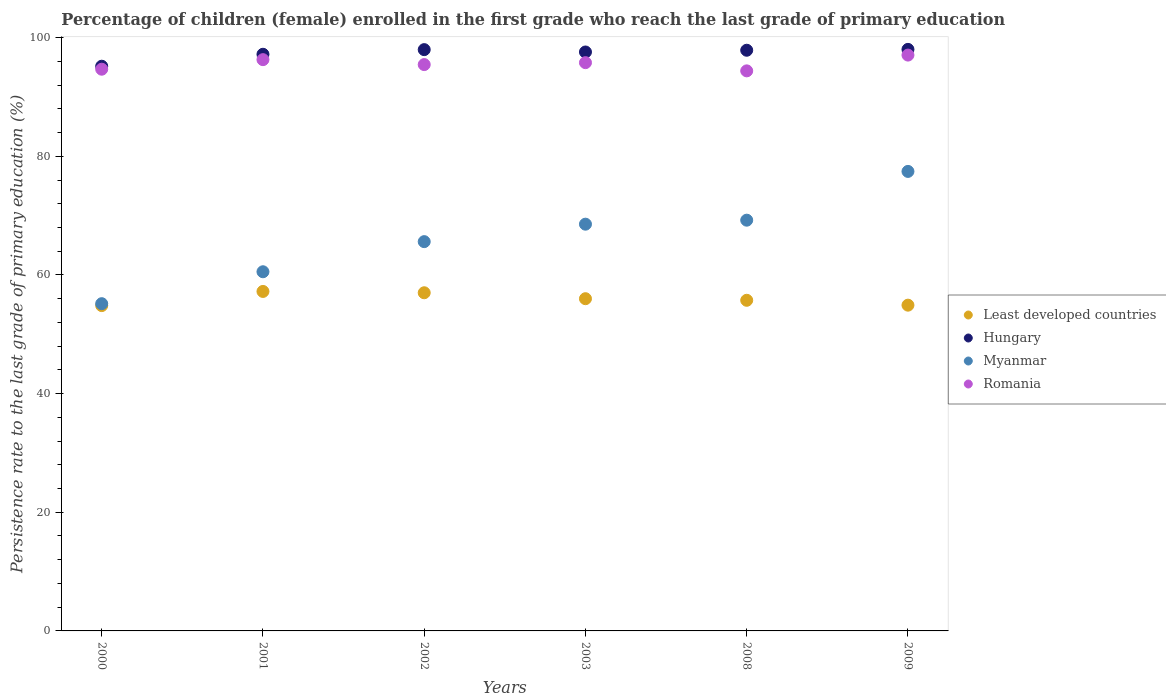What is the persistence rate of children in Romania in 2001?
Provide a short and direct response. 96.29. Across all years, what is the maximum persistence rate of children in Romania?
Make the answer very short. 97.06. Across all years, what is the minimum persistence rate of children in Romania?
Your answer should be compact. 94.4. In which year was the persistence rate of children in Myanmar maximum?
Provide a short and direct response. 2009. In which year was the persistence rate of children in Hungary minimum?
Provide a succinct answer. 2000. What is the total persistence rate of children in Least developed countries in the graph?
Provide a short and direct response. 335.69. What is the difference between the persistence rate of children in Least developed countries in 2000 and that in 2009?
Make the answer very short. -0.07. What is the difference between the persistence rate of children in Least developed countries in 2001 and the persistence rate of children in Romania in 2008?
Keep it short and to the point. -37.18. What is the average persistence rate of children in Least developed countries per year?
Keep it short and to the point. 55.95. In the year 2009, what is the difference between the persistence rate of children in Hungary and persistence rate of children in Romania?
Offer a very short reply. 0.96. What is the ratio of the persistence rate of children in Least developed countries in 2000 to that in 2003?
Provide a short and direct response. 0.98. Is the persistence rate of children in Myanmar in 2003 less than that in 2008?
Provide a succinct answer. Yes. What is the difference between the highest and the second highest persistence rate of children in Hungary?
Keep it short and to the point. 0.04. What is the difference between the highest and the lowest persistence rate of children in Least developed countries?
Make the answer very short. 2.38. In how many years, is the persistence rate of children in Myanmar greater than the average persistence rate of children in Myanmar taken over all years?
Keep it short and to the point. 3. Is it the case that in every year, the sum of the persistence rate of children in Myanmar and persistence rate of children in Hungary  is greater than the sum of persistence rate of children in Least developed countries and persistence rate of children in Romania?
Provide a short and direct response. No. Is it the case that in every year, the sum of the persistence rate of children in Hungary and persistence rate of children in Myanmar  is greater than the persistence rate of children in Romania?
Offer a very short reply. Yes. Is the persistence rate of children in Romania strictly greater than the persistence rate of children in Myanmar over the years?
Provide a succinct answer. Yes. What is the difference between two consecutive major ticks on the Y-axis?
Give a very brief answer. 20. Are the values on the major ticks of Y-axis written in scientific E-notation?
Provide a short and direct response. No. How are the legend labels stacked?
Ensure brevity in your answer.  Vertical. What is the title of the graph?
Give a very brief answer. Percentage of children (female) enrolled in the first grade who reach the last grade of primary education. What is the label or title of the Y-axis?
Make the answer very short. Persistence rate to the last grade of primary education (%). What is the Persistence rate to the last grade of primary education (%) in Least developed countries in 2000?
Make the answer very short. 54.84. What is the Persistence rate to the last grade of primary education (%) of Hungary in 2000?
Offer a very short reply. 95.18. What is the Persistence rate to the last grade of primary education (%) of Myanmar in 2000?
Your answer should be compact. 55.16. What is the Persistence rate to the last grade of primary education (%) of Romania in 2000?
Your answer should be very brief. 94.68. What is the Persistence rate to the last grade of primary education (%) in Least developed countries in 2001?
Your response must be concise. 57.22. What is the Persistence rate to the last grade of primary education (%) of Hungary in 2001?
Keep it short and to the point. 97.19. What is the Persistence rate to the last grade of primary education (%) in Myanmar in 2001?
Keep it short and to the point. 60.54. What is the Persistence rate to the last grade of primary education (%) of Romania in 2001?
Your response must be concise. 96.29. What is the Persistence rate to the last grade of primary education (%) in Least developed countries in 2002?
Ensure brevity in your answer.  57. What is the Persistence rate to the last grade of primary education (%) of Hungary in 2002?
Provide a succinct answer. 97.98. What is the Persistence rate to the last grade of primary education (%) of Myanmar in 2002?
Offer a very short reply. 65.61. What is the Persistence rate to the last grade of primary education (%) of Romania in 2002?
Provide a short and direct response. 95.46. What is the Persistence rate to the last grade of primary education (%) of Least developed countries in 2003?
Your response must be concise. 56. What is the Persistence rate to the last grade of primary education (%) in Hungary in 2003?
Give a very brief answer. 97.58. What is the Persistence rate to the last grade of primary education (%) in Myanmar in 2003?
Ensure brevity in your answer.  68.56. What is the Persistence rate to the last grade of primary education (%) of Romania in 2003?
Your response must be concise. 95.78. What is the Persistence rate to the last grade of primary education (%) of Least developed countries in 2008?
Offer a terse response. 55.73. What is the Persistence rate to the last grade of primary education (%) of Hungary in 2008?
Offer a terse response. 97.88. What is the Persistence rate to the last grade of primary education (%) of Myanmar in 2008?
Your response must be concise. 69.23. What is the Persistence rate to the last grade of primary education (%) of Romania in 2008?
Ensure brevity in your answer.  94.4. What is the Persistence rate to the last grade of primary education (%) of Least developed countries in 2009?
Offer a terse response. 54.91. What is the Persistence rate to the last grade of primary education (%) in Hungary in 2009?
Provide a short and direct response. 98.02. What is the Persistence rate to the last grade of primary education (%) of Myanmar in 2009?
Your answer should be compact. 77.45. What is the Persistence rate to the last grade of primary education (%) of Romania in 2009?
Keep it short and to the point. 97.06. Across all years, what is the maximum Persistence rate to the last grade of primary education (%) of Least developed countries?
Give a very brief answer. 57.22. Across all years, what is the maximum Persistence rate to the last grade of primary education (%) of Hungary?
Your response must be concise. 98.02. Across all years, what is the maximum Persistence rate to the last grade of primary education (%) of Myanmar?
Your answer should be compact. 77.45. Across all years, what is the maximum Persistence rate to the last grade of primary education (%) of Romania?
Make the answer very short. 97.06. Across all years, what is the minimum Persistence rate to the last grade of primary education (%) in Least developed countries?
Provide a succinct answer. 54.84. Across all years, what is the minimum Persistence rate to the last grade of primary education (%) in Hungary?
Your answer should be very brief. 95.18. Across all years, what is the minimum Persistence rate to the last grade of primary education (%) of Myanmar?
Offer a terse response. 55.16. Across all years, what is the minimum Persistence rate to the last grade of primary education (%) in Romania?
Ensure brevity in your answer.  94.4. What is the total Persistence rate to the last grade of primary education (%) of Least developed countries in the graph?
Your answer should be compact. 335.69. What is the total Persistence rate to the last grade of primary education (%) of Hungary in the graph?
Your response must be concise. 583.83. What is the total Persistence rate to the last grade of primary education (%) in Myanmar in the graph?
Your response must be concise. 396.55. What is the total Persistence rate to the last grade of primary education (%) of Romania in the graph?
Provide a succinct answer. 573.67. What is the difference between the Persistence rate to the last grade of primary education (%) in Least developed countries in 2000 and that in 2001?
Offer a very short reply. -2.38. What is the difference between the Persistence rate to the last grade of primary education (%) of Hungary in 2000 and that in 2001?
Keep it short and to the point. -2.01. What is the difference between the Persistence rate to the last grade of primary education (%) of Myanmar in 2000 and that in 2001?
Your answer should be compact. -5.38. What is the difference between the Persistence rate to the last grade of primary education (%) of Romania in 2000 and that in 2001?
Your answer should be compact. -1.61. What is the difference between the Persistence rate to the last grade of primary education (%) of Least developed countries in 2000 and that in 2002?
Offer a very short reply. -2.16. What is the difference between the Persistence rate to the last grade of primary education (%) in Hungary in 2000 and that in 2002?
Give a very brief answer. -2.8. What is the difference between the Persistence rate to the last grade of primary education (%) of Myanmar in 2000 and that in 2002?
Your response must be concise. -10.46. What is the difference between the Persistence rate to the last grade of primary education (%) in Romania in 2000 and that in 2002?
Provide a short and direct response. -0.78. What is the difference between the Persistence rate to the last grade of primary education (%) of Least developed countries in 2000 and that in 2003?
Give a very brief answer. -1.16. What is the difference between the Persistence rate to the last grade of primary education (%) of Hungary in 2000 and that in 2003?
Offer a very short reply. -2.4. What is the difference between the Persistence rate to the last grade of primary education (%) in Myanmar in 2000 and that in 2003?
Provide a short and direct response. -13.4. What is the difference between the Persistence rate to the last grade of primary education (%) of Romania in 2000 and that in 2003?
Keep it short and to the point. -1.11. What is the difference between the Persistence rate to the last grade of primary education (%) of Least developed countries in 2000 and that in 2008?
Offer a very short reply. -0.89. What is the difference between the Persistence rate to the last grade of primary education (%) of Hungary in 2000 and that in 2008?
Offer a very short reply. -2.69. What is the difference between the Persistence rate to the last grade of primary education (%) of Myanmar in 2000 and that in 2008?
Provide a short and direct response. -14.08. What is the difference between the Persistence rate to the last grade of primary education (%) in Romania in 2000 and that in 2008?
Make the answer very short. 0.28. What is the difference between the Persistence rate to the last grade of primary education (%) of Least developed countries in 2000 and that in 2009?
Give a very brief answer. -0.07. What is the difference between the Persistence rate to the last grade of primary education (%) in Hungary in 2000 and that in 2009?
Make the answer very short. -2.84. What is the difference between the Persistence rate to the last grade of primary education (%) in Myanmar in 2000 and that in 2009?
Provide a succinct answer. -22.29. What is the difference between the Persistence rate to the last grade of primary education (%) of Romania in 2000 and that in 2009?
Offer a terse response. -2.38. What is the difference between the Persistence rate to the last grade of primary education (%) of Least developed countries in 2001 and that in 2002?
Your response must be concise. 0.22. What is the difference between the Persistence rate to the last grade of primary education (%) in Hungary in 2001 and that in 2002?
Ensure brevity in your answer.  -0.78. What is the difference between the Persistence rate to the last grade of primary education (%) of Myanmar in 2001 and that in 2002?
Give a very brief answer. -5.08. What is the difference between the Persistence rate to the last grade of primary education (%) of Romania in 2001 and that in 2002?
Give a very brief answer. 0.83. What is the difference between the Persistence rate to the last grade of primary education (%) of Least developed countries in 2001 and that in 2003?
Your response must be concise. 1.22. What is the difference between the Persistence rate to the last grade of primary education (%) of Hungary in 2001 and that in 2003?
Your answer should be very brief. -0.39. What is the difference between the Persistence rate to the last grade of primary education (%) of Myanmar in 2001 and that in 2003?
Provide a short and direct response. -8.02. What is the difference between the Persistence rate to the last grade of primary education (%) of Romania in 2001 and that in 2003?
Provide a succinct answer. 0.51. What is the difference between the Persistence rate to the last grade of primary education (%) in Least developed countries in 2001 and that in 2008?
Provide a short and direct response. 1.49. What is the difference between the Persistence rate to the last grade of primary education (%) in Hungary in 2001 and that in 2008?
Offer a very short reply. -0.68. What is the difference between the Persistence rate to the last grade of primary education (%) of Myanmar in 2001 and that in 2008?
Your answer should be very brief. -8.69. What is the difference between the Persistence rate to the last grade of primary education (%) of Romania in 2001 and that in 2008?
Keep it short and to the point. 1.89. What is the difference between the Persistence rate to the last grade of primary education (%) of Least developed countries in 2001 and that in 2009?
Keep it short and to the point. 2.31. What is the difference between the Persistence rate to the last grade of primary education (%) in Hungary in 2001 and that in 2009?
Keep it short and to the point. -0.82. What is the difference between the Persistence rate to the last grade of primary education (%) of Myanmar in 2001 and that in 2009?
Keep it short and to the point. -16.91. What is the difference between the Persistence rate to the last grade of primary education (%) in Romania in 2001 and that in 2009?
Make the answer very short. -0.77. What is the difference between the Persistence rate to the last grade of primary education (%) in Hungary in 2002 and that in 2003?
Give a very brief answer. 0.4. What is the difference between the Persistence rate to the last grade of primary education (%) of Myanmar in 2002 and that in 2003?
Give a very brief answer. -2.94. What is the difference between the Persistence rate to the last grade of primary education (%) in Romania in 2002 and that in 2003?
Offer a very short reply. -0.33. What is the difference between the Persistence rate to the last grade of primary education (%) of Least developed countries in 2002 and that in 2008?
Your answer should be compact. 1.27. What is the difference between the Persistence rate to the last grade of primary education (%) of Hungary in 2002 and that in 2008?
Your answer should be compact. 0.1. What is the difference between the Persistence rate to the last grade of primary education (%) of Myanmar in 2002 and that in 2008?
Give a very brief answer. -3.62. What is the difference between the Persistence rate to the last grade of primary education (%) in Romania in 2002 and that in 2008?
Keep it short and to the point. 1.06. What is the difference between the Persistence rate to the last grade of primary education (%) of Least developed countries in 2002 and that in 2009?
Ensure brevity in your answer.  2.09. What is the difference between the Persistence rate to the last grade of primary education (%) of Hungary in 2002 and that in 2009?
Your answer should be very brief. -0.04. What is the difference between the Persistence rate to the last grade of primary education (%) of Myanmar in 2002 and that in 2009?
Provide a succinct answer. -11.84. What is the difference between the Persistence rate to the last grade of primary education (%) of Romania in 2002 and that in 2009?
Your answer should be compact. -1.6. What is the difference between the Persistence rate to the last grade of primary education (%) of Least developed countries in 2003 and that in 2008?
Your answer should be compact. 0.27. What is the difference between the Persistence rate to the last grade of primary education (%) in Hungary in 2003 and that in 2008?
Offer a terse response. -0.29. What is the difference between the Persistence rate to the last grade of primary education (%) of Myanmar in 2003 and that in 2008?
Your answer should be very brief. -0.67. What is the difference between the Persistence rate to the last grade of primary education (%) of Romania in 2003 and that in 2008?
Offer a very short reply. 1.38. What is the difference between the Persistence rate to the last grade of primary education (%) of Least developed countries in 2003 and that in 2009?
Provide a short and direct response. 1.09. What is the difference between the Persistence rate to the last grade of primary education (%) in Hungary in 2003 and that in 2009?
Give a very brief answer. -0.44. What is the difference between the Persistence rate to the last grade of primary education (%) in Myanmar in 2003 and that in 2009?
Provide a short and direct response. -8.89. What is the difference between the Persistence rate to the last grade of primary education (%) in Romania in 2003 and that in 2009?
Your response must be concise. -1.27. What is the difference between the Persistence rate to the last grade of primary education (%) in Least developed countries in 2008 and that in 2009?
Your answer should be compact. 0.82. What is the difference between the Persistence rate to the last grade of primary education (%) in Hungary in 2008 and that in 2009?
Offer a very short reply. -0.14. What is the difference between the Persistence rate to the last grade of primary education (%) in Myanmar in 2008 and that in 2009?
Provide a short and direct response. -8.22. What is the difference between the Persistence rate to the last grade of primary education (%) in Romania in 2008 and that in 2009?
Your answer should be very brief. -2.66. What is the difference between the Persistence rate to the last grade of primary education (%) in Least developed countries in 2000 and the Persistence rate to the last grade of primary education (%) in Hungary in 2001?
Make the answer very short. -42.36. What is the difference between the Persistence rate to the last grade of primary education (%) in Least developed countries in 2000 and the Persistence rate to the last grade of primary education (%) in Myanmar in 2001?
Offer a very short reply. -5.7. What is the difference between the Persistence rate to the last grade of primary education (%) in Least developed countries in 2000 and the Persistence rate to the last grade of primary education (%) in Romania in 2001?
Your answer should be very brief. -41.45. What is the difference between the Persistence rate to the last grade of primary education (%) of Hungary in 2000 and the Persistence rate to the last grade of primary education (%) of Myanmar in 2001?
Offer a very short reply. 34.64. What is the difference between the Persistence rate to the last grade of primary education (%) in Hungary in 2000 and the Persistence rate to the last grade of primary education (%) in Romania in 2001?
Make the answer very short. -1.11. What is the difference between the Persistence rate to the last grade of primary education (%) of Myanmar in 2000 and the Persistence rate to the last grade of primary education (%) of Romania in 2001?
Give a very brief answer. -41.13. What is the difference between the Persistence rate to the last grade of primary education (%) of Least developed countries in 2000 and the Persistence rate to the last grade of primary education (%) of Hungary in 2002?
Your answer should be very brief. -43.14. What is the difference between the Persistence rate to the last grade of primary education (%) of Least developed countries in 2000 and the Persistence rate to the last grade of primary education (%) of Myanmar in 2002?
Make the answer very short. -10.78. What is the difference between the Persistence rate to the last grade of primary education (%) in Least developed countries in 2000 and the Persistence rate to the last grade of primary education (%) in Romania in 2002?
Your answer should be compact. -40.62. What is the difference between the Persistence rate to the last grade of primary education (%) in Hungary in 2000 and the Persistence rate to the last grade of primary education (%) in Myanmar in 2002?
Your answer should be compact. 29.57. What is the difference between the Persistence rate to the last grade of primary education (%) of Hungary in 2000 and the Persistence rate to the last grade of primary education (%) of Romania in 2002?
Make the answer very short. -0.28. What is the difference between the Persistence rate to the last grade of primary education (%) of Myanmar in 2000 and the Persistence rate to the last grade of primary education (%) of Romania in 2002?
Provide a succinct answer. -40.3. What is the difference between the Persistence rate to the last grade of primary education (%) of Least developed countries in 2000 and the Persistence rate to the last grade of primary education (%) of Hungary in 2003?
Provide a succinct answer. -42.74. What is the difference between the Persistence rate to the last grade of primary education (%) in Least developed countries in 2000 and the Persistence rate to the last grade of primary education (%) in Myanmar in 2003?
Give a very brief answer. -13.72. What is the difference between the Persistence rate to the last grade of primary education (%) in Least developed countries in 2000 and the Persistence rate to the last grade of primary education (%) in Romania in 2003?
Keep it short and to the point. -40.95. What is the difference between the Persistence rate to the last grade of primary education (%) of Hungary in 2000 and the Persistence rate to the last grade of primary education (%) of Myanmar in 2003?
Provide a succinct answer. 26.62. What is the difference between the Persistence rate to the last grade of primary education (%) of Hungary in 2000 and the Persistence rate to the last grade of primary education (%) of Romania in 2003?
Provide a short and direct response. -0.6. What is the difference between the Persistence rate to the last grade of primary education (%) in Myanmar in 2000 and the Persistence rate to the last grade of primary education (%) in Romania in 2003?
Give a very brief answer. -40.63. What is the difference between the Persistence rate to the last grade of primary education (%) in Least developed countries in 2000 and the Persistence rate to the last grade of primary education (%) in Hungary in 2008?
Offer a very short reply. -43.04. What is the difference between the Persistence rate to the last grade of primary education (%) of Least developed countries in 2000 and the Persistence rate to the last grade of primary education (%) of Myanmar in 2008?
Give a very brief answer. -14.4. What is the difference between the Persistence rate to the last grade of primary education (%) in Least developed countries in 2000 and the Persistence rate to the last grade of primary education (%) in Romania in 2008?
Provide a short and direct response. -39.56. What is the difference between the Persistence rate to the last grade of primary education (%) in Hungary in 2000 and the Persistence rate to the last grade of primary education (%) in Myanmar in 2008?
Your answer should be very brief. 25.95. What is the difference between the Persistence rate to the last grade of primary education (%) in Hungary in 2000 and the Persistence rate to the last grade of primary education (%) in Romania in 2008?
Make the answer very short. 0.78. What is the difference between the Persistence rate to the last grade of primary education (%) of Myanmar in 2000 and the Persistence rate to the last grade of primary education (%) of Romania in 2008?
Your answer should be compact. -39.24. What is the difference between the Persistence rate to the last grade of primary education (%) in Least developed countries in 2000 and the Persistence rate to the last grade of primary education (%) in Hungary in 2009?
Provide a short and direct response. -43.18. What is the difference between the Persistence rate to the last grade of primary education (%) in Least developed countries in 2000 and the Persistence rate to the last grade of primary education (%) in Myanmar in 2009?
Your response must be concise. -22.61. What is the difference between the Persistence rate to the last grade of primary education (%) of Least developed countries in 2000 and the Persistence rate to the last grade of primary education (%) of Romania in 2009?
Make the answer very short. -42.22. What is the difference between the Persistence rate to the last grade of primary education (%) in Hungary in 2000 and the Persistence rate to the last grade of primary education (%) in Myanmar in 2009?
Ensure brevity in your answer.  17.73. What is the difference between the Persistence rate to the last grade of primary education (%) in Hungary in 2000 and the Persistence rate to the last grade of primary education (%) in Romania in 2009?
Offer a very short reply. -1.88. What is the difference between the Persistence rate to the last grade of primary education (%) in Myanmar in 2000 and the Persistence rate to the last grade of primary education (%) in Romania in 2009?
Give a very brief answer. -41.9. What is the difference between the Persistence rate to the last grade of primary education (%) of Least developed countries in 2001 and the Persistence rate to the last grade of primary education (%) of Hungary in 2002?
Keep it short and to the point. -40.76. What is the difference between the Persistence rate to the last grade of primary education (%) of Least developed countries in 2001 and the Persistence rate to the last grade of primary education (%) of Myanmar in 2002?
Give a very brief answer. -8.39. What is the difference between the Persistence rate to the last grade of primary education (%) of Least developed countries in 2001 and the Persistence rate to the last grade of primary education (%) of Romania in 2002?
Provide a succinct answer. -38.24. What is the difference between the Persistence rate to the last grade of primary education (%) of Hungary in 2001 and the Persistence rate to the last grade of primary education (%) of Myanmar in 2002?
Your answer should be very brief. 31.58. What is the difference between the Persistence rate to the last grade of primary education (%) in Hungary in 2001 and the Persistence rate to the last grade of primary education (%) in Romania in 2002?
Your response must be concise. 1.74. What is the difference between the Persistence rate to the last grade of primary education (%) of Myanmar in 2001 and the Persistence rate to the last grade of primary education (%) of Romania in 2002?
Offer a very short reply. -34.92. What is the difference between the Persistence rate to the last grade of primary education (%) in Least developed countries in 2001 and the Persistence rate to the last grade of primary education (%) in Hungary in 2003?
Make the answer very short. -40.36. What is the difference between the Persistence rate to the last grade of primary education (%) in Least developed countries in 2001 and the Persistence rate to the last grade of primary education (%) in Myanmar in 2003?
Ensure brevity in your answer.  -11.34. What is the difference between the Persistence rate to the last grade of primary education (%) of Least developed countries in 2001 and the Persistence rate to the last grade of primary education (%) of Romania in 2003?
Ensure brevity in your answer.  -38.56. What is the difference between the Persistence rate to the last grade of primary education (%) in Hungary in 2001 and the Persistence rate to the last grade of primary education (%) in Myanmar in 2003?
Give a very brief answer. 28.64. What is the difference between the Persistence rate to the last grade of primary education (%) of Hungary in 2001 and the Persistence rate to the last grade of primary education (%) of Romania in 2003?
Keep it short and to the point. 1.41. What is the difference between the Persistence rate to the last grade of primary education (%) in Myanmar in 2001 and the Persistence rate to the last grade of primary education (%) in Romania in 2003?
Your answer should be compact. -35.25. What is the difference between the Persistence rate to the last grade of primary education (%) of Least developed countries in 2001 and the Persistence rate to the last grade of primary education (%) of Hungary in 2008?
Give a very brief answer. -40.66. What is the difference between the Persistence rate to the last grade of primary education (%) of Least developed countries in 2001 and the Persistence rate to the last grade of primary education (%) of Myanmar in 2008?
Ensure brevity in your answer.  -12.01. What is the difference between the Persistence rate to the last grade of primary education (%) of Least developed countries in 2001 and the Persistence rate to the last grade of primary education (%) of Romania in 2008?
Offer a very short reply. -37.18. What is the difference between the Persistence rate to the last grade of primary education (%) in Hungary in 2001 and the Persistence rate to the last grade of primary education (%) in Myanmar in 2008?
Your answer should be very brief. 27.96. What is the difference between the Persistence rate to the last grade of primary education (%) of Hungary in 2001 and the Persistence rate to the last grade of primary education (%) of Romania in 2008?
Provide a succinct answer. 2.79. What is the difference between the Persistence rate to the last grade of primary education (%) of Myanmar in 2001 and the Persistence rate to the last grade of primary education (%) of Romania in 2008?
Your answer should be very brief. -33.86. What is the difference between the Persistence rate to the last grade of primary education (%) in Least developed countries in 2001 and the Persistence rate to the last grade of primary education (%) in Hungary in 2009?
Provide a short and direct response. -40.8. What is the difference between the Persistence rate to the last grade of primary education (%) in Least developed countries in 2001 and the Persistence rate to the last grade of primary education (%) in Myanmar in 2009?
Provide a succinct answer. -20.23. What is the difference between the Persistence rate to the last grade of primary education (%) of Least developed countries in 2001 and the Persistence rate to the last grade of primary education (%) of Romania in 2009?
Give a very brief answer. -39.84. What is the difference between the Persistence rate to the last grade of primary education (%) of Hungary in 2001 and the Persistence rate to the last grade of primary education (%) of Myanmar in 2009?
Make the answer very short. 19.74. What is the difference between the Persistence rate to the last grade of primary education (%) of Hungary in 2001 and the Persistence rate to the last grade of primary education (%) of Romania in 2009?
Give a very brief answer. 0.14. What is the difference between the Persistence rate to the last grade of primary education (%) in Myanmar in 2001 and the Persistence rate to the last grade of primary education (%) in Romania in 2009?
Your answer should be compact. -36.52. What is the difference between the Persistence rate to the last grade of primary education (%) of Least developed countries in 2002 and the Persistence rate to the last grade of primary education (%) of Hungary in 2003?
Your answer should be very brief. -40.58. What is the difference between the Persistence rate to the last grade of primary education (%) of Least developed countries in 2002 and the Persistence rate to the last grade of primary education (%) of Myanmar in 2003?
Your answer should be very brief. -11.56. What is the difference between the Persistence rate to the last grade of primary education (%) in Least developed countries in 2002 and the Persistence rate to the last grade of primary education (%) in Romania in 2003?
Give a very brief answer. -38.79. What is the difference between the Persistence rate to the last grade of primary education (%) in Hungary in 2002 and the Persistence rate to the last grade of primary education (%) in Myanmar in 2003?
Your answer should be very brief. 29.42. What is the difference between the Persistence rate to the last grade of primary education (%) in Hungary in 2002 and the Persistence rate to the last grade of primary education (%) in Romania in 2003?
Ensure brevity in your answer.  2.19. What is the difference between the Persistence rate to the last grade of primary education (%) in Myanmar in 2002 and the Persistence rate to the last grade of primary education (%) in Romania in 2003?
Offer a terse response. -30.17. What is the difference between the Persistence rate to the last grade of primary education (%) in Least developed countries in 2002 and the Persistence rate to the last grade of primary education (%) in Hungary in 2008?
Provide a succinct answer. -40.88. What is the difference between the Persistence rate to the last grade of primary education (%) in Least developed countries in 2002 and the Persistence rate to the last grade of primary education (%) in Myanmar in 2008?
Your answer should be compact. -12.23. What is the difference between the Persistence rate to the last grade of primary education (%) in Least developed countries in 2002 and the Persistence rate to the last grade of primary education (%) in Romania in 2008?
Give a very brief answer. -37.4. What is the difference between the Persistence rate to the last grade of primary education (%) in Hungary in 2002 and the Persistence rate to the last grade of primary education (%) in Myanmar in 2008?
Provide a short and direct response. 28.75. What is the difference between the Persistence rate to the last grade of primary education (%) in Hungary in 2002 and the Persistence rate to the last grade of primary education (%) in Romania in 2008?
Your response must be concise. 3.58. What is the difference between the Persistence rate to the last grade of primary education (%) of Myanmar in 2002 and the Persistence rate to the last grade of primary education (%) of Romania in 2008?
Offer a terse response. -28.79. What is the difference between the Persistence rate to the last grade of primary education (%) in Least developed countries in 2002 and the Persistence rate to the last grade of primary education (%) in Hungary in 2009?
Your answer should be very brief. -41.02. What is the difference between the Persistence rate to the last grade of primary education (%) of Least developed countries in 2002 and the Persistence rate to the last grade of primary education (%) of Myanmar in 2009?
Give a very brief answer. -20.45. What is the difference between the Persistence rate to the last grade of primary education (%) of Least developed countries in 2002 and the Persistence rate to the last grade of primary education (%) of Romania in 2009?
Your response must be concise. -40.06. What is the difference between the Persistence rate to the last grade of primary education (%) in Hungary in 2002 and the Persistence rate to the last grade of primary education (%) in Myanmar in 2009?
Your answer should be very brief. 20.53. What is the difference between the Persistence rate to the last grade of primary education (%) of Hungary in 2002 and the Persistence rate to the last grade of primary education (%) of Romania in 2009?
Provide a short and direct response. 0.92. What is the difference between the Persistence rate to the last grade of primary education (%) in Myanmar in 2002 and the Persistence rate to the last grade of primary education (%) in Romania in 2009?
Ensure brevity in your answer.  -31.44. What is the difference between the Persistence rate to the last grade of primary education (%) of Least developed countries in 2003 and the Persistence rate to the last grade of primary education (%) of Hungary in 2008?
Ensure brevity in your answer.  -41.88. What is the difference between the Persistence rate to the last grade of primary education (%) of Least developed countries in 2003 and the Persistence rate to the last grade of primary education (%) of Myanmar in 2008?
Give a very brief answer. -13.24. What is the difference between the Persistence rate to the last grade of primary education (%) of Least developed countries in 2003 and the Persistence rate to the last grade of primary education (%) of Romania in 2008?
Make the answer very short. -38.4. What is the difference between the Persistence rate to the last grade of primary education (%) in Hungary in 2003 and the Persistence rate to the last grade of primary education (%) in Myanmar in 2008?
Ensure brevity in your answer.  28.35. What is the difference between the Persistence rate to the last grade of primary education (%) of Hungary in 2003 and the Persistence rate to the last grade of primary education (%) of Romania in 2008?
Offer a very short reply. 3.18. What is the difference between the Persistence rate to the last grade of primary education (%) in Myanmar in 2003 and the Persistence rate to the last grade of primary education (%) in Romania in 2008?
Give a very brief answer. -25.84. What is the difference between the Persistence rate to the last grade of primary education (%) in Least developed countries in 2003 and the Persistence rate to the last grade of primary education (%) in Hungary in 2009?
Give a very brief answer. -42.02. What is the difference between the Persistence rate to the last grade of primary education (%) of Least developed countries in 2003 and the Persistence rate to the last grade of primary education (%) of Myanmar in 2009?
Your response must be concise. -21.45. What is the difference between the Persistence rate to the last grade of primary education (%) of Least developed countries in 2003 and the Persistence rate to the last grade of primary education (%) of Romania in 2009?
Make the answer very short. -41.06. What is the difference between the Persistence rate to the last grade of primary education (%) in Hungary in 2003 and the Persistence rate to the last grade of primary education (%) in Myanmar in 2009?
Offer a terse response. 20.13. What is the difference between the Persistence rate to the last grade of primary education (%) in Hungary in 2003 and the Persistence rate to the last grade of primary education (%) in Romania in 2009?
Your answer should be very brief. 0.52. What is the difference between the Persistence rate to the last grade of primary education (%) of Myanmar in 2003 and the Persistence rate to the last grade of primary education (%) of Romania in 2009?
Your response must be concise. -28.5. What is the difference between the Persistence rate to the last grade of primary education (%) in Least developed countries in 2008 and the Persistence rate to the last grade of primary education (%) in Hungary in 2009?
Keep it short and to the point. -42.29. What is the difference between the Persistence rate to the last grade of primary education (%) in Least developed countries in 2008 and the Persistence rate to the last grade of primary education (%) in Myanmar in 2009?
Your response must be concise. -21.72. What is the difference between the Persistence rate to the last grade of primary education (%) of Least developed countries in 2008 and the Persistence rate to the last grade of primary education (%) of Romania in 2009?
Your answer should be very brief. -41.33. What is the difference between the Persistence rate to the last grade of primary education (%) of Hungary in 2008 and the Persistence rate to the last grade of primary education (%) of Myanmar in 2009?
Make the answer very short. 20.42. What is the difference between the Persistence rate to the last grade of primary education (%) in Hungary in 2008 and the Persistence rate to the last grade of primary education (%) in Romania in 2009?
Offer a very short reply. 0.82. What is the difference between the Persistence rate to the last grade of primary education (%) in Myanmar in 2008 and the Persistence rate to the last grade of primary education (%) in Romania in 2009?
Ensure brevity in your answer.  -27.83. What is the average Persistence rate to the last grade of primary education (%) of Least developed countries per year?
Ensure brevity in your answer.  55.95. What is the average Persistence rate to the last grade of primary education (%) in Hungary per year?
Your response must be concise. 97.31. What is the average Persistence rate to the last grade of primary education (%) of Myanmar per year?
Offer a terse response. 66.09. What is the average Persistence rate to the last grade of primary education (%) of Romania per year?
Offer a terse response. 95.61. In the year 2000, what is the difference between the Persistence rate to the last grade of primary education (%) in Least developed countries and Persistence rate to the last grade of primary education (%) in Hungary?
Your answer should be compact. -40.35. In the year 2000, what is the difference between the Persistence rate to the last grade of primary education (%) in Least developed countries and Persistence rate to the last grade of primary education (%) in Myanmar?
Give a very brief answer. -0.32. In the year 2000, what is the difference between the Persistence rate to the last grade of primary education (%) of Least developed countries and Persistence rate to the last grade of primary education (%) of Romania?
Provide a succinct answer. -39.84. In the year 2000, what is the difference between the Persistence rate to the last grade of primary education (%) of Hungary and Persistence rate to the last grade of primary education (%) of Myanmar?
Your response must be concise. 40.03. In the year 2000, what is the difference between the Persistence rate to the last grade of primary education (%) of Hungary and Persistence rate to the last grade of primary education (%) of Romania?
Offer a very short reply. 0.5. In the year 2000, what is the difference between the Persistence rate to the last grade of primary education (%) of Myanmar and Persistence rate to the last grade of primary education (%) of Romania?
Offer a very short reply. -39.52. In the year 2001, what is the difference between the Persistence rate to the last grade of primary education (%) in Least developed countries and Persistence rate to the last grade of primary education (%) in Hungary?
Provide a succinct answer. -39.98. In the year 2001, what is the difference between the Persistence rate to the last grade of primary education (%) of Least developed countries and Persistence rate to the last grade of primary education (%) of Myanmar?
Provide a short and direct response. -3.32. In the year 2001, what is the difference between the Persistence rate to the last grade of primary education (%) of Least developed countries and Persistence rate to the last grade of primary education (%) of Romania?
Your answer should be compact. -39.07. In the year 2001, what is the difference between the Persistence rate to the last grade of primary education (%) in Hungary and Persistence rate to the last grade of primary education (%) in Myanmar?
Your answer should be compact. 36.66. In the year 2001, what is the difference between the Persistence rate to the last grade of primary education (%) of Hungary and Persistence rate to the last grade of primary education (%) of Romania?
Your answer should be compact. 0.91. In the year 2001, what is the difference between the Persistence rate to the last grade of primary education (%) in Myanmar and Persistence rate to the last grade of primary education (%) in Romania?
Keep it short and to the point. -35.75. In the year 2002, what is the difference between the Persistence rate to the last grade of primary education (%) in Least developed countries and Persistence rate to the last grade of primary education (%) in Hungary?
Make the answer very short. -40.98. In the year 2002, what is the difference between the Persistence rate to the last grade of primary education (%) in Least developed countries and Persistence rate to the last grade of primary education (%) in Myanmar?
Your answer should be very brief. -8.62. In the year 2002, what is the difference between the Persistence rate to the last grade of primary education (%) of Least developed countries and Persistence rate to the last grade of primary education (%) of Romania?
Your response must be concise. -38.46. In the year 2002, what is the difference between the Persistence rate to the last grade of primary education (%) of Hungary and Persistence rate to the last grade of primary education (%) of Myanmar?
Your answer should be very brief. 32.36. In the year 2002, what is the difference between the Persistence rate to the last grade of primary education (%) in Hungary and Persistence rate to the last grade of primary education (%) in Romania?
Your answer should be compact. 2.52. In the year 2002, what is the difference between the Persistence rate to the last grade of primary education (%) in Myanmar and Persistence rate to the last grade of primary education (%) in Romania?
Your response must be concise. -29.84. In the year 2003, what is the difference between the Persistence rate to the last grade of primary education (%) in Least developed countries and Persistence rate to the last grade of primary education (%) in Hungary?
Your answer should be very brief. -41.58. In the year 2003, what is the difference between the Persistence rate to the last grade of primary education (%) of Least developed countries and Persistence rate to the last grade of primary education (%) of Myanmar?
Ensure brevity in your answer.  -12.56. In the year 2003, what is the difference between the Persistence rate to the last grade of primary education (%) of Least developed countries and Persistence rate to the last grade of primary education (%) of Romania?
Your answer should be very brief. -39.79. In the year 2003, what is the difference between the Persistence rate to the last grade of primary education (%) in Hungary and Persistence rate to the last grade of primary education (%) in Myanmar?
Keep it short and to the point. 29.02. In the year 2003, what is the difference between the Persistence rate to the last grade of primary education (%) in Hungary and Persistence rate to the last grade of primary education (%) in Romania?
Make the answer very short. 1.8. In the year 2003, what is the difference between the Persistence rate to the last grade of primary education (%) in Myanmar and Persistence rate to the last grade of primary education (%) in Romania?
Offer a very short reply. -27.23. In the year 2008, what is the difference between the Persistence rate to the last grade of primary education (%) in Least developed countries and Persistence rate to the last grade of primary education (%) in Hungary?
Provide a short and direct response. -42.15. In the year 2008, what is the difference between the Persistence rate to the last grade of primary education (%) in Least developed countries and Persistence rate to the last grade of primary education (%) in Myanmar?
Give a very brief answer. -13.5. In the year 2008, what is the difference between the Persistence rate to the last grade of primary education (%) in Least developed countries and Persistence rate to the last grade of primary education (%) in Romania?
Keep it short and to the point. -38.67. In the year 2008, what is the difference between the Persistence rate to the last grade of primary education (%) of Hungary and Persistence rate to the last grade of primary education (%) of Myanmar?
Offer a very short reply. 28.64. In the year 2008, what is the difference between the Persistence rate to the last grade of primary education (%) of Hungary and Persistence rate to the last grade of primary education (%) of Romania?
Make the answer very short. 3.48. In the year 2008, what is the difference between the Persistence rate to the last grade of primary education (%) of Myanmar and Persistence rate to the last grade of primary education (%) of Romania?
Your response must be concise. -25.17. In the year 2009, what is the difference between the Persistence rate to the last grade of primary education (%) in Least developed countries and Persistence rate to the last grade of primary education (%) in Hungary?
Provide a succinct answer. -43.11. In the year 2009, what is the difference between the Persistence rate to the last grade of primary education (%) in Least developed countries and Persistence rate to the last grade of primary education (%) in Myanmar?
Offer a very short reply. -22.54. In the year 2009, what is the difference between the Persistence rate to the last grade of primary education (%) in Least developed countries and Persistence rate to the last grade of primary education (%) in Romania?
Offer a terse response. -42.15. In the year 2009, what is the difference between the Persistence rate to the last grade of primary education (%) in Hungary and Persistence rate to the last grade of primary education (%) in Myanmar?
Provide a succinct answer. 20.57. In the year 2009, what is the difference between the Persistence rate to the last grade of primary education (%) in Hungary and Persistence rate to the last grade of primary education (%) in Romania?
Your answer should be compact. 0.96. In the year 2009, what is the difference between the Persistence rate to the last grade of primary education (%) in Myanmar and Persistence rate to the last grade of primary education (%) in Romania?
Keep it short and to the point. -19.61. What is the ratio of the Persistence rate to the last grade of primary education (%) in Hungary in 2000 to that in 2001?
Give a very brief answer. 0.98. What is the ratio of the Persistence rate to the last grade of primary education (%) of Myanmar in 2000 to that in 2001?
Keep it short and to the point. 0.91. What is the ratio of the Persistence rate to the last grade of primary education (%) of Romania in 2000 to that in 2001?
Provide a succinct answer. 0.98. What is the ratio of the Persistence rate to the last grade of primary education (%) of Least developed countries in 2000 to that in 2002?
Your answer should be very brief. 0.96. What is the ratio of the Persistence rate to the last grade of primary education (%) of Hungary in 2000 to that in 2002?
Your answer should be very brief. 0.97. What is the ratio of the Persistence rate to the last grade of primary education (%) of Myanmar in 2000 to that in 2002?
Ensure brevity in your answer.  0.84. What is the ratio of the Persistence rate to the last grade of primary education (%) of Least developed countries in 2000 to that in 2003?
Your response must be concise. 0.98. What is the ratio of the Persistence rate to the last grade of primary education (%) of Hungary in 2000 to that in 2003?
Provide a succinct answer. 0.98. What is the ratio of the Persistence rate to the last grade of primary education (%) of Myanmar in 2000 to that in 2003?
Ensure brevity in your answer.  0.8. What is the ratio of the Persistence rate to the last grade of primary education (%) in Hungary in 2000 to that in 2008?
Make the answer very short. 0.97. What is the ratio of the Persistence rate to the last grade of primary education (%) in Myanmar in 2000 to that in 2008?
Offer a terse response. 0.8. What is the ratio of the Persistence rate to the last grade of primary education (%) in Romania in 2000 to that in 2008?
Give a very brief answer. 1. What is the ratio of the Persistence rate to the last grade of primary education (%) in Hungary in 2000 to that in 2009?
Give a very brief answer. 0.97. What is the ratio of the Persistence rate to the last grade of primary education (%) in Myanmar in 2000 to that in 2009?
Provide a succinct answer. 0.71. What is the ratio of the Persistence rate to the last grade of primary education (%) of Romania in 2000 to that in 2009?
Offer a very short reply. 0.98. What is the ratio of the Persistence rate to the last grade of primary education (%) of Least developed countries in 2001 to that in 2002?
Offer a terse response. 1. What is the ratio of the Persistence rate to the last grade of primary education (%) in Myanmar in 2001 to that in 2002?
Ensure brevity in your answer.  0.92. What is the ratio of the Persistence rate to the last grade of primary education (%) of Romania in 2001 to that in 2002?
Provide a succinct answer. 1.01. What is the ratio of the Persistence rate to the last grade of primary education (%) in Least developed countries in 2001 to that in 2003?
Give a very brief answer. 1.02. What is the ratio of the Persistence rate to the last grade of primary education (%) of Hungary in 2001 to that in 2003?
Make the answer very short. 1. What is the ratio of the Persistence rate to the last grade of primary education (%) in Myanmar in 2001 to that in 2003?
Keep it short and to the point. 0.88. What is the ratio of the Persistence rate to the last grade of primary education (%) in Least developed countries in 2001 to that in 2008?
Provide a short and direct response. 1.03. What is the ratio of the Persistence rate to the last grade of primary education (%) of Myanmar in 2001 to that in 2008?
Keep it short and to the point. 0.87. What is the ratio of the Persistence rate to the last grade of primary education (%) of Romania in 2001 to that in 2008?
Your answer should be compact. 1.02. What is the ratio of the Persistence rate to the last grade of primary education (%) in Least developed countries in 2001 to that in 2009?
Give a very brief answer. 1.04. What is the ratio of the Persistence rate to the last grade of primary education (%) of Myanmar in 2001 to that in 2009?
Give a very brief answer. 0.78. What is the ratio of the Persistence rate to the last grade of primary education (%) of Romania in 2001 to that in 2009?
Offer a terse response. 0.99. What is the ratio of the Persistence rate to the last grade of primary education (%) in Least developed countries in 2002 to that in 2003?
Provide a succinct answer. 1.02. What is the ratio of the Persistence rate to the last grade of primary education (%) in Myanmar in 2002 to that in 2003?
Give a very brief answer. 0.96. What is the ratio of the Persistence rate to the last grade of primary education (%) of Least developed countries in 2002 to that in 2008?
Your response must be concise. 1.02. What is the ratio of the Persistence rate to the last grade of primary education (%) of Hungary in 2002 to that in 2008?
Your answer should be compact. 1. What is the ratio of the Persistence rate to the last grade of primary education (%) of Myanmar in 2002 to that in 2008?
Offer a very short reply. 0.95. What is the ratio of the Persistence rate to the last grade of primary education (%) in Romania in 2002 to that in 2008?
Offer a very short reply. 1.01. What is the ratio of the Persistence rate to the last grade of primary education (%) of Least developed countries in 2002 to that in 2009?
Offer a very short reply. 1.04. What is the ratio of the Persistence rate to the last grade of primary education (%) in Hungary in 2002 to that in 2009?
Ensure brevity in your answer.  1. What is the ratio of the Persistence rate to the last grade of primary education (%) of Myanmar in 2002 to that in 2009?
Make the answer very short. 0.85. What is the ratio of the Persistence rate to the last grade of primary education (%) of Romania in 2002 to that in 2009?
Provide a short and direct response. 0.98. What is the ratio of the Persistence rate to the last grade of primary education (%) of Myanmar in 2003 to that in 2008?
Provide a succinct answer. 0.99. What is the ratio of the Persistence rate to the last grade of primary education (%) in Romania in 2003 to that in 2008?
Provide a short and direct response. 1.01. What is the ratio of the Persistence rate to the last grade of primary education (%) in Least developed countries in 2003 to that in 2009?
Offer a terse response. 1.02. What is the ratio of the Persistence rate to the last grade of primary education (%) in Hungary in 2003 to that in 2009?
Give a very brief answer. 1. What is the ratio of the Persistence rate to the last grade of primary education (%) in Myanmar in 2003 to that in 2009?
Offer a terse response. 0.89. What is the ratio of the Persistence rate to the last grade of primary education (%) of Romania in 2003 to that in 2009?
Your answer should be compact. 0.99. What is the ratio of the Persistence rate to the last grade of primary education (%) in Myanmar in 2008 to that in 2009?
Keep it short and to the point. 0.89. What is the ratio of the Persistence rate to the last grade of primary education (%) in Romania in 2008 to that in 2009?
Keep it short and to the point. 0.97. What is the difference between the highest and the second highest Persistence rate to the last grade of primary education (%) in Least developed countries?
Make the answer very short. 0.22. What is the difference between the highest and the second highest Persistence rate to the last grade of primary education (%) in Hungary?
Provide a succinct answer. 0.04. What is the difference between the highest and the second highest Persistence rate to the last grade of primary education (%) of Myanmar?
Ensure brevity in your answer.  8.22. What is the difference between the highest and the second highest Persistence rate to the last grade of primary education (%) of Romania?
Offer a very short reply. 0.77. What is the difference between the highest and the lowest Persistence rate to the last grade of primary education (%) of Least developed countries?
Keep it short and to the point. 2.38. What is the difference between the highest and the lowest Persistence rate to the last grade of primary education (%) of Hungary?
Your answer should be compact. 2.84. What is the difference between the highest and the lowest Persistence rate to the last grade of primary education (%) in Myanmar?
Your answer should be compact. 22.29. What is the difference between the highest and the lowest Persistence rate to the last grade of primary education (%) in Romania?
Give a very brief answer. 2.66. 